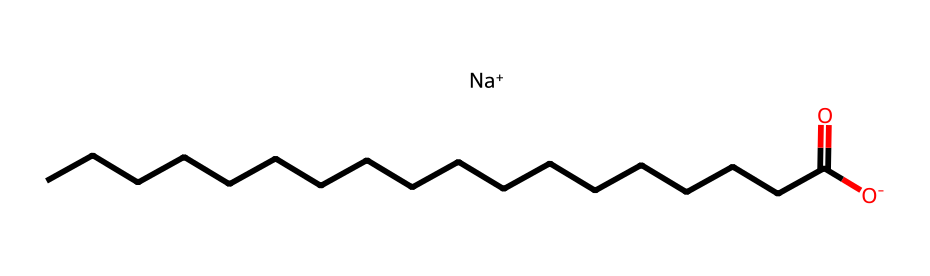What is the molecular formula of sodium stearate? From the SMILES representation, we can see that the component includes sodium (Na), carbon (C), hydrogen (H), and oxygen (O). By counting the carbon atoms in the long hydrocarbon chain, there are 18 carbons, indicating C18. There’s one sodium and one oxygen in the functional group at the end, combined with references to the hydrogens associated with the carbon chain leads to the formula being NaC18H35O2.
Answer: NaC18H35O2 How many carbon atoms are present in sodium stearate? The SMILES representation shows a long chain with 18 carbon (C) atoms connected in sequence. The C count can be seen directly from the chemical structure provided.
Answer: 18 What type of chemical bond connects the carbon atoms in the hydrocarbon chain? The carbon atoms in the hydrocarbon chain of sodium stearate are connected by single covalent bonds, as evidenced by the structure showing simple connections between the carbon atoms without indication of double or triple bonds.
Answer: single covalent What is the charge on the sodium ion in sodium stearate? The SMILES representation indicates that the sodium ion (Na+) carries a positive charge, as denoted by the plus sign next to Na. The sodium is in its ionic form, which is crucial for its function in soaps.
Answer: positive What role does the carboxylate group play in sodium stearate? The carboxylate group (-COO-) is responsible for the soap's ability to emulsify oils and fats, allowing them to mix with water for cleansing. This functional group allows the molecule to interact with both hydrophilic and hydrophobic substances.
Answer: emulsification How many hydrogen atoms are associated with the carbon chain in sodium stearate? In the molecular structure, the carbon chain (C18) is fully saturated, suggesting it has the maximum number of hydrogens connected to the carbon atoms. The general formula for saturated hydrocarbons is CnH2n+2, so for C18, there would be 35 hydrogens.
Answer: 35 Why is sodium stearate effective for hand washing? Sodium stearate functions effectively in hand washing due to its amphiphilic nature; it has both hydrophilic (water-attracting) and hydrophobic (water-repelling) properties, allowing it to lift and disperse dirt and oils from skin surfaces during washing.
Answer: amphiphilic nature 